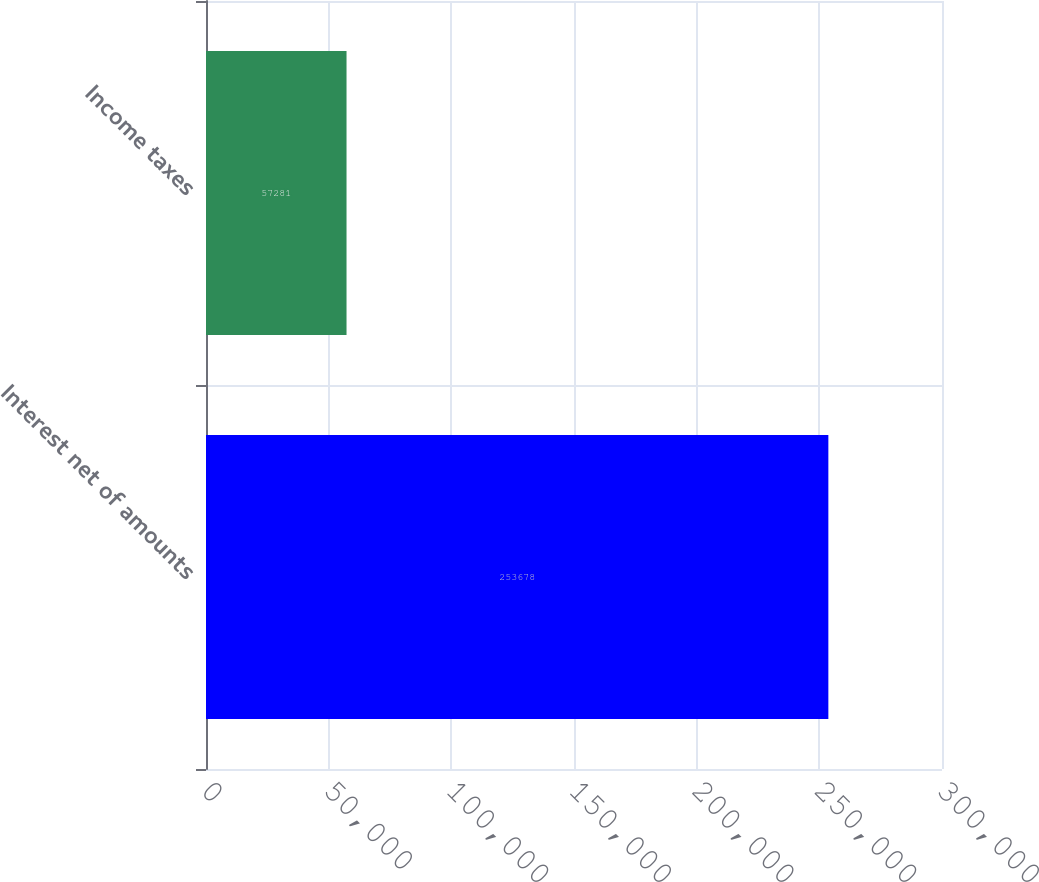Convert chart to OTSL. <chart><loc_0><loc_0><loc_500><loc_500><bar_chart><fcel>Interest net of amounts<fcel>Income taxes<nl><fcel>253678<fcel>57281<nl></chart> 